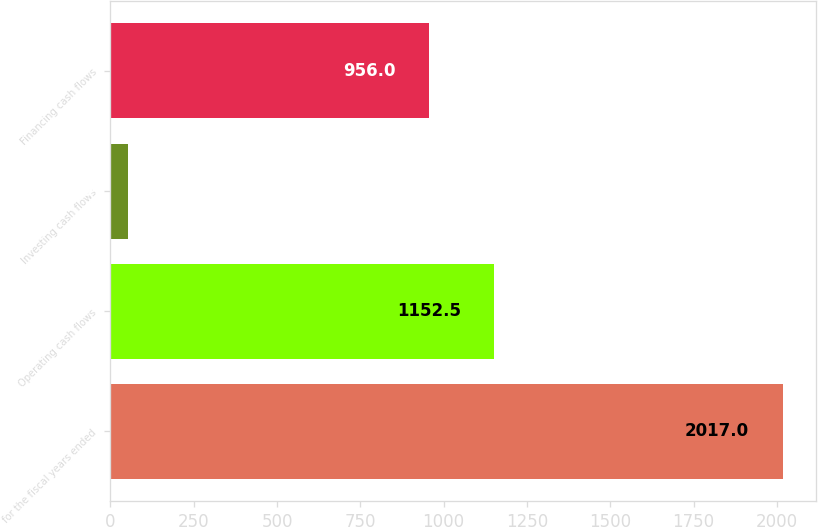Convert chart. <chart><loc_0><loc_0><loc_500><loc_500><bar_chart><fcel>for the fiscal years ended<fcel>Operating cash flows<fcel>Investing cash flows<fcel>Financing cash flows<nl><fcel>2017<fcel>1152.5<fcel>52<fcel>956<nl></chart> 